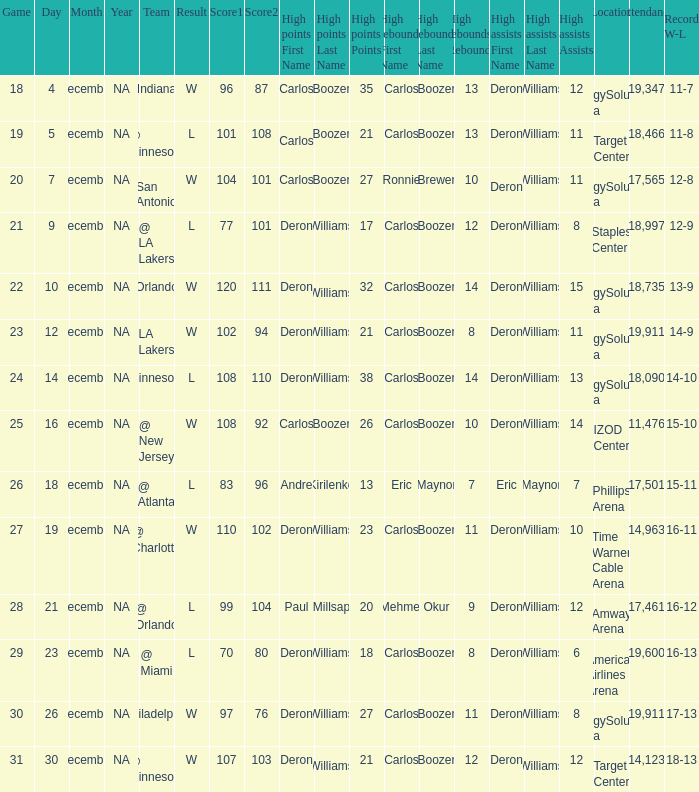When was the game in which Deron Williams (13) did the high assists played? December 14. 